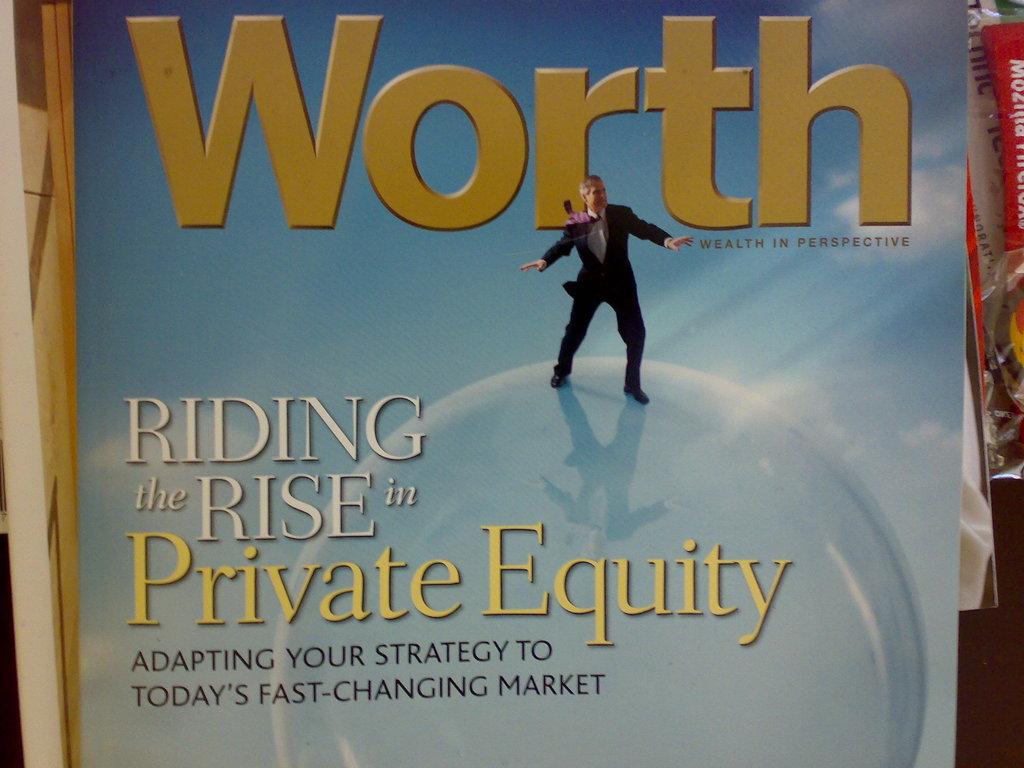What is the book called?
Your response must be concise. Worth. 